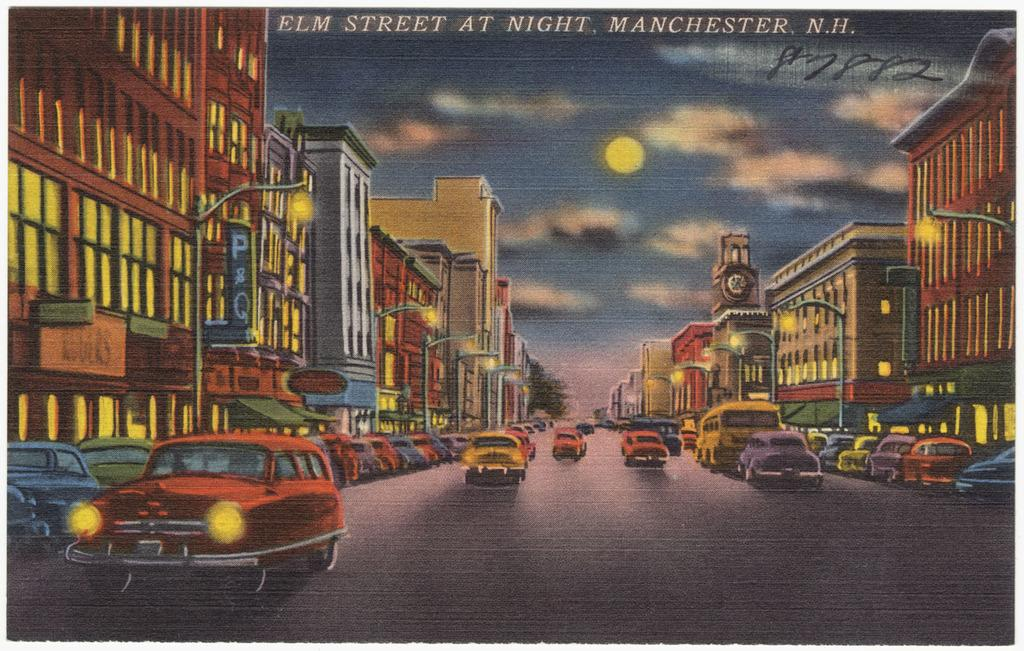<image>
Provide a brief description of the given image. A cartoon picture of Elm Street at night. 